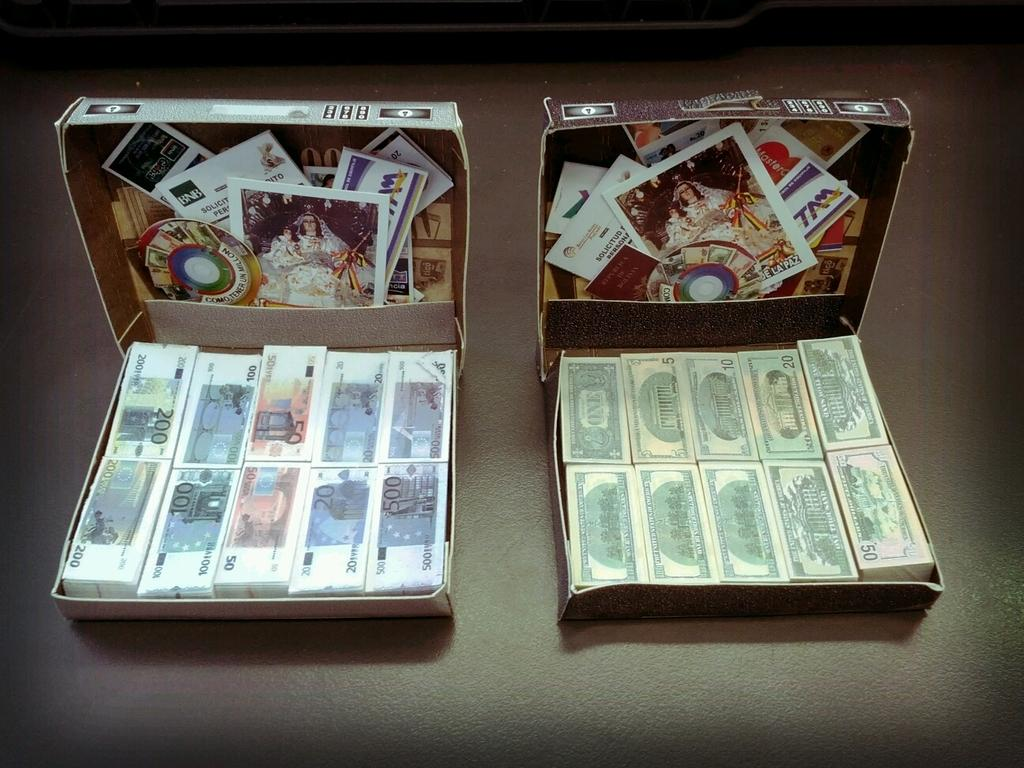How many boxes are present in the image? There are two boxes in the image. Where are the boxes located? The boxes are on surfaces. What items can be found inside the boxes? There are currency notes and posters in the boxes. What type of church can be seen in the wilderness in the image? There is no church or wilderness present in the image; it features two boxes on surfaces with currency notes and posters inside. How is the oven used in the image? There is no oven present in the image. 